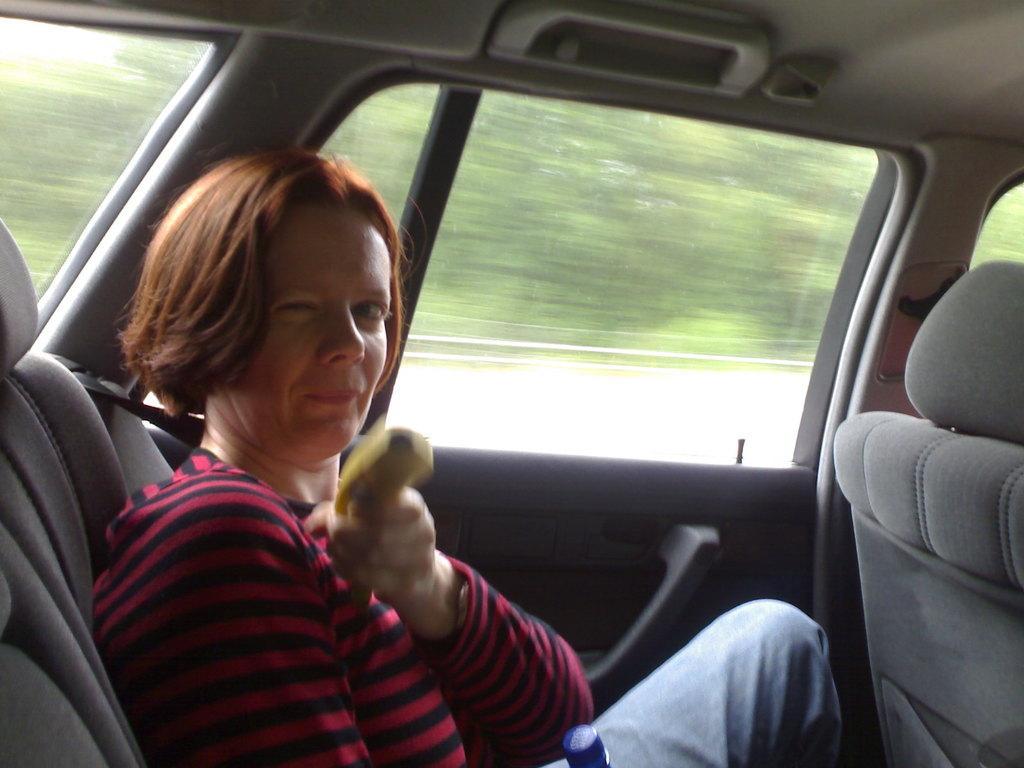In one or two sentences, can you explain what this image depicts? in a picture there is a woman sitting in a car. 